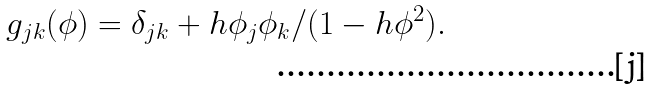Convert formula to latex. <formula><loc_0><loc_0><loc_500><loc_500>g _ { j k } ( \phi ) = \delta _ { j k } + h \phi _ { j } \phi _ { k } / ( 1 - h \phi ^ { 2 } ) .</formula> 